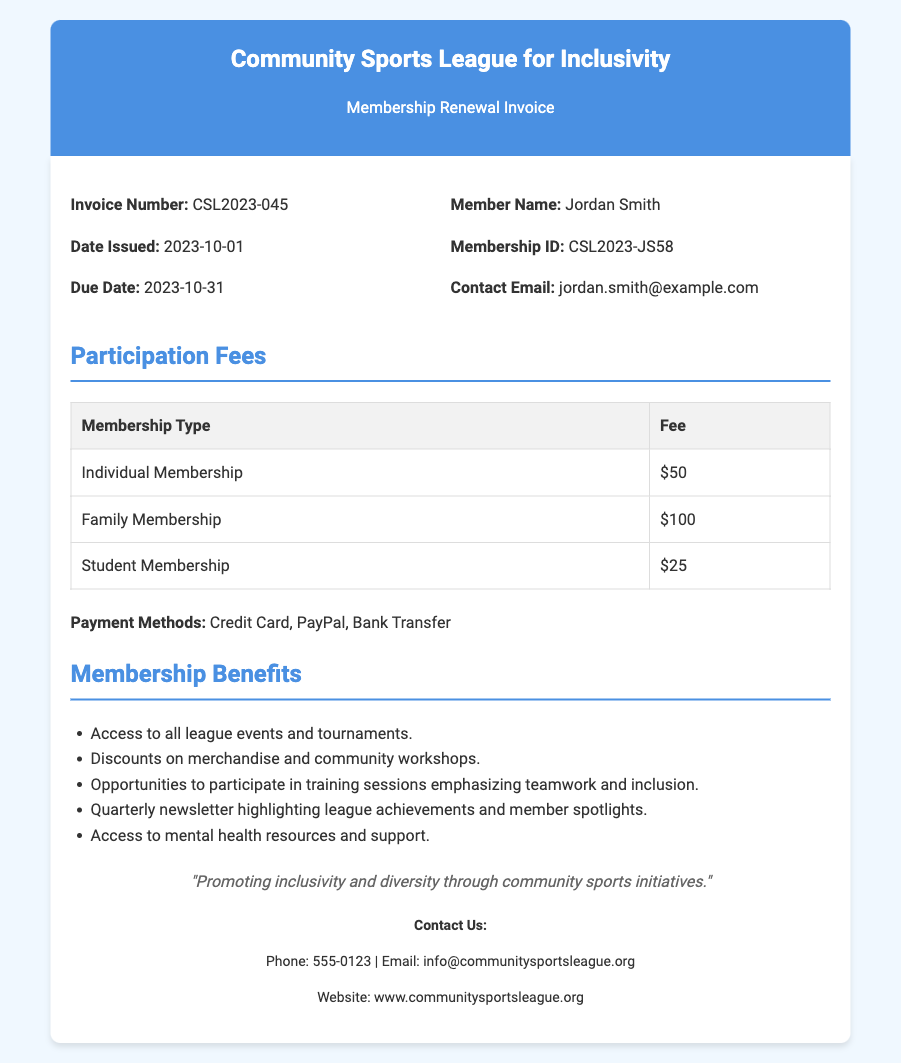What is the invoice number? The invoice number is specified in the document to identify this particular invoice.
Answer: CSL2023-045 What is the date issued? The date issued is found in the invoice details, indicating when the invoice was created.
Answer: 2023-10-01 What is the membership type with the highest fee? The membership types listed indicate the fee structure, from which the highest can be identified.
Answer: Family Membership What are the payment methods available? The document lists the accepted payment methods for the membership fees.
Answer: Credit Card, PayPal, Bank Transfer How much is the fee for a student membership? The document specifies the participation fees in a table format, listing the fee for each membership type.
Answer: $25 What is the main mission of the league? The mission statement at the end of the document provides insight into the league's purpose.
Answer: Promoting inclusivity and diversity through community sports initiatives What benefits do members receive? The list of membership benefits provides insight into what members gain by renewing their membership.
Answer: Access to all league events and tournaments, Discounts on merchandise and community workshops, Opportunities to participate in training sessions emphasizing teamwork and inclusion, Quarterly newsletter highlighting league achievements and member spotlights, Access to mental health resources and support When is the due date for payment? The due date is provided in the invoice details for timely payment.
Answer: 2023-10-31 What is the contact email for inquiries? The document provides contact information for members who may have questions or need assistance.
Answer: info@communitysportsleague.org 